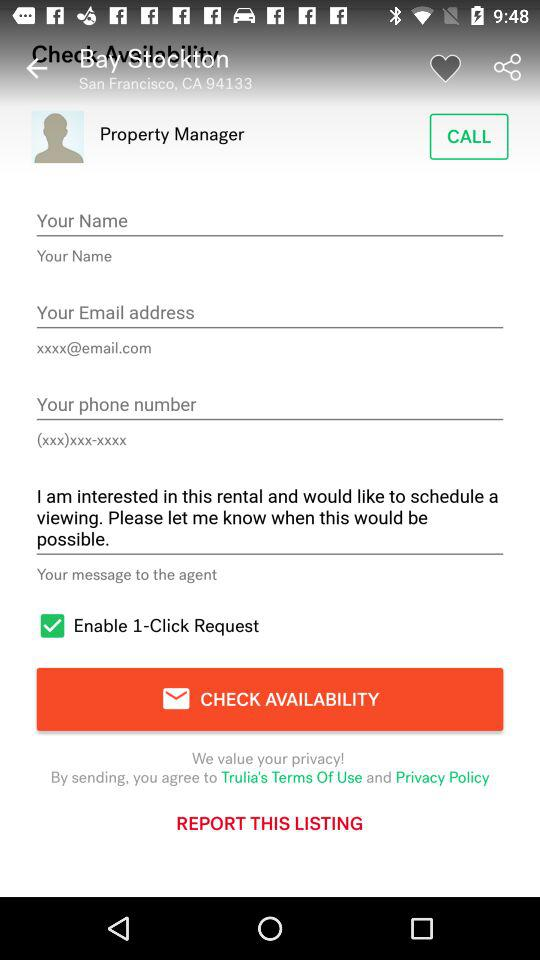What is the current location of Bay Stockton? The current location of Bay Stockton is San Francisco, CA 94133. 